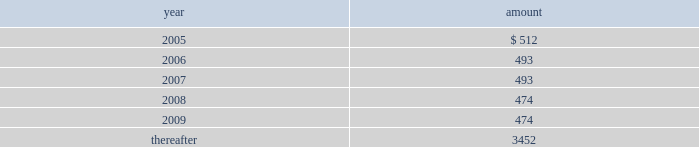Commitments and contingencies rental expense related to office , warehouse space and real estate amounted to $ 608 , $ 324 , and $ 281 for the years ended december 25 , 2004 , december 27 , 2003 , and december 28 , 2002 , respectively .
Future minimum lease payments are as follows : at december 25 , 2004 , the company expects future costs of approximately $ 900 for the completion of its facility expansion in olathe , kansas .
Certain cash balances of gel are held as collateral by a bank securing payment of the united kingdom value-added tax requirements .
These amounted to $ 1457 and $ 1602 at december 25 , 2004 and december 27 , 2003 , respectively , and are reported as restricted cash .
In the normal course of business , the company and its subsidiaries are parties to various legal claims , actions , and complaints , including matters involving patent infringement and other intellectual property claims and various other risks .
It is not possible to predict with certainty whether or not the company and its subsidiaries will ultimately be successful in any of these legal matters , or if not , what the impact might be .
However , the company 2019s management does not expect that the results in any of these legal proceedings will have a material adverse effect on the company 2019s results of operations , financial position or cash flows .
Employee benefit plans gii sponsors an employee retirement plan under which its employees may contribute up to 50% ( 50 % ) of their annual compensation subject to internal revenue code maximum limitations and to which gii contributes a specified percentage of each participant 2019s annual compensation up to certain limits as defined in the plan .
Additionally , gel has a defined contribution plan under which its employees may contribute up to 5% ( 5 % ) of their annual compensation .
Both gii and gel contribute an amount determined annually at the discretion of the board of directors .
During the years ended december 25 , 2004 , december 27 , 2003 , and december 28 , 2002 , expense related to these plans of $ 5183 , $ 4197 , and $ 2728 , respectively , was charged to operations .
Certain of the company 2019s foreign subsidiaries participate in local defined benefit pension plans .
Contributions are calculated by formulas that consider final pensionable salaries .
Neither obligations nor contributions for the years ended december 25 , 2004 , december 27 , 2003 , and december 28 , 2002 were significant. .

What is the increase in expense related to office , warehouse space , and real estate during 2003 and 2004? 
Rationale: it is the difference between those two values .
Computations: (608 - 324)
Answer: 284.0. 